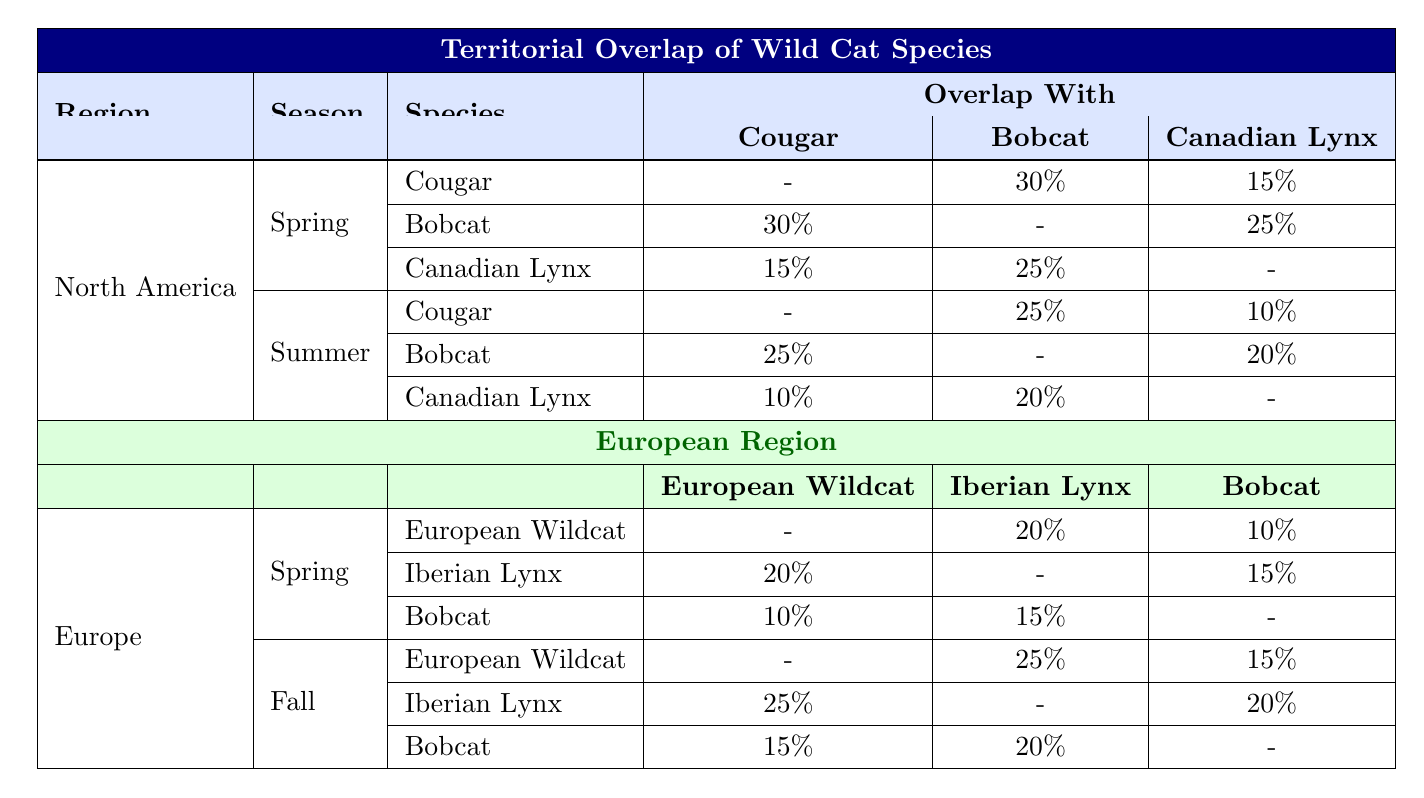What percentage of territorial overlap exists between Cougars and Bobcats in North America during Spring? In the North America section under Spring, Cougars have a territorial overlap of 30% with Bobcats.
Answer: 30% Which species has the highest overlap with the Bobcat in the Summer season in North America? In the North America Summer section, Bobcats have a higher overlap with Cougars (25%) compared to Canadian Lynx (20%). So, Cougars have the highest overlap with Bobcats.
Answer: Cougars Is there any territorial overlap between the European Wildcat and the Bobcat during Spring? Yes, the table indicates that the European Wildcat has a territorial overlap of 10% with the Bobcat in the Spring season.
Answer: Yes What is the total territorial overlap percentage of the European Wildcat with both the Iberian Lynx and the Bobcat in the Spring season? The European Wildcat has a 20% overlap with the Iberian Lynx and a 10% overlap with the Bobcat during Spring. Adding these together, the total overlap is 20% + 10% = 30%.
Answer: 30% Does the Cougar have a lower overlap with the Canadian Lynx in Summer compared to Spring? Yes, in Summer, the Cougar has a 10% overlap with the Canadian Lynx, which is lower than the 15% overlap reported in Spring.
Answer: Yes Which species has the least overlap with the Cougar in both Spring and Summer? In Spring, the Cougar has a 15% overlap with the Canadian Lynx, and in Summer, it also has a 10% overlap with the Canadian Lynx. The least overlap in both seasons is with the Canadian Lynx.
Answer: Canadian Lynx What is the difference in overlap percentages between the Iberian Lynx and Bobcat during the Fall season in Europe? In the Fall season, Iberian Lynx has a 20% overlap with the Bobcat, while Bobcat has a 15% overlap with the European Wildcat. The difference calculated is 20% - 15% = 5%.
Answer: 5% How does the overlap between Cougar and Canadian Lynx in Spring compare to their overlap in Summer? In Spring, the Cougar has a 15% overlap with Canadian Lynx, while in Summer, the overlap decreases to 10%. Thus, the overlap in Spring (15%) is greater than in Summer (10%).
Answer: Greater in Spring What is the total overlap of the Bobcat with all other species in North America for both Spring and Summer? In Spring, Bobcat has overlaps of 30% (Cougar) and 25% (Canadian Lynx), totaling 55%. In Summer, Bobcat overlaps 25% (Cougar) and 20% (Canadian Lynx), totaling 45%. The grand total for both seasons is 55% + 45% = 100%.
Answer: 100% 